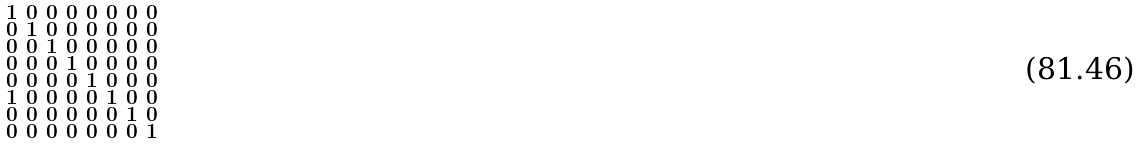<formula> <loc_0><loc_0><loc_500><loc_500>\begin{smallmatrix} 1 & 0 & 0 & 0 & 0 & 0 & 0 & 0 \\ 0 & 1 & 0 & 0 & 0 & 0 & 0 & 0 \\ 0 & 0 & 1 & 0 & 0 & 0 & 0 & 0 \\ 0 & 0 & 0 & 1 & 0 & 0 & 0 & 0 \\ 0 & 0 & 0 & 0 & 1 & 0 & 0 & 0 \\ 1 & 0 & 0 & 0 & 0 & 1 & 0 & 0 \\ 0 & 0 & 0 & 0 & 0 & 0 & 1 & 0 \\ 0 & 0 & 0 & 0 & 0 & 0 & 0 & 1 \end{smallmatrix}</formula> 